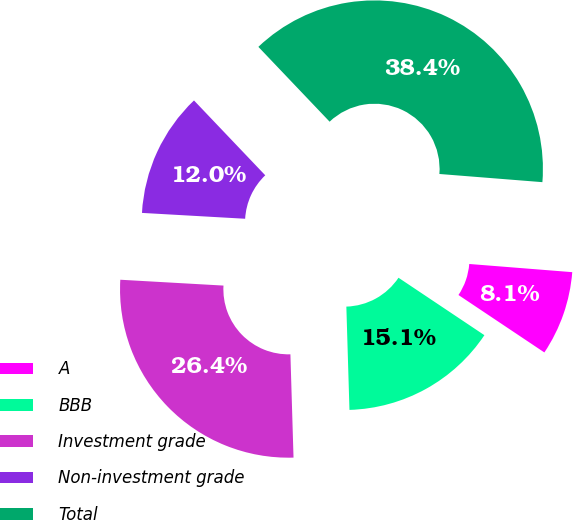Convert chart. <chart><loc_0><loc_0><loc_500><loc_500><pie_chart><fcel>A<fcel>BBB<fcel>Investment grade<fcel>Non-investment grade<fcel>Total<nl><fcel>8.12%<fcel>15.14%<fcel>26.38%<fcel>11.99%<fcel>38.37%<nl></chart> 